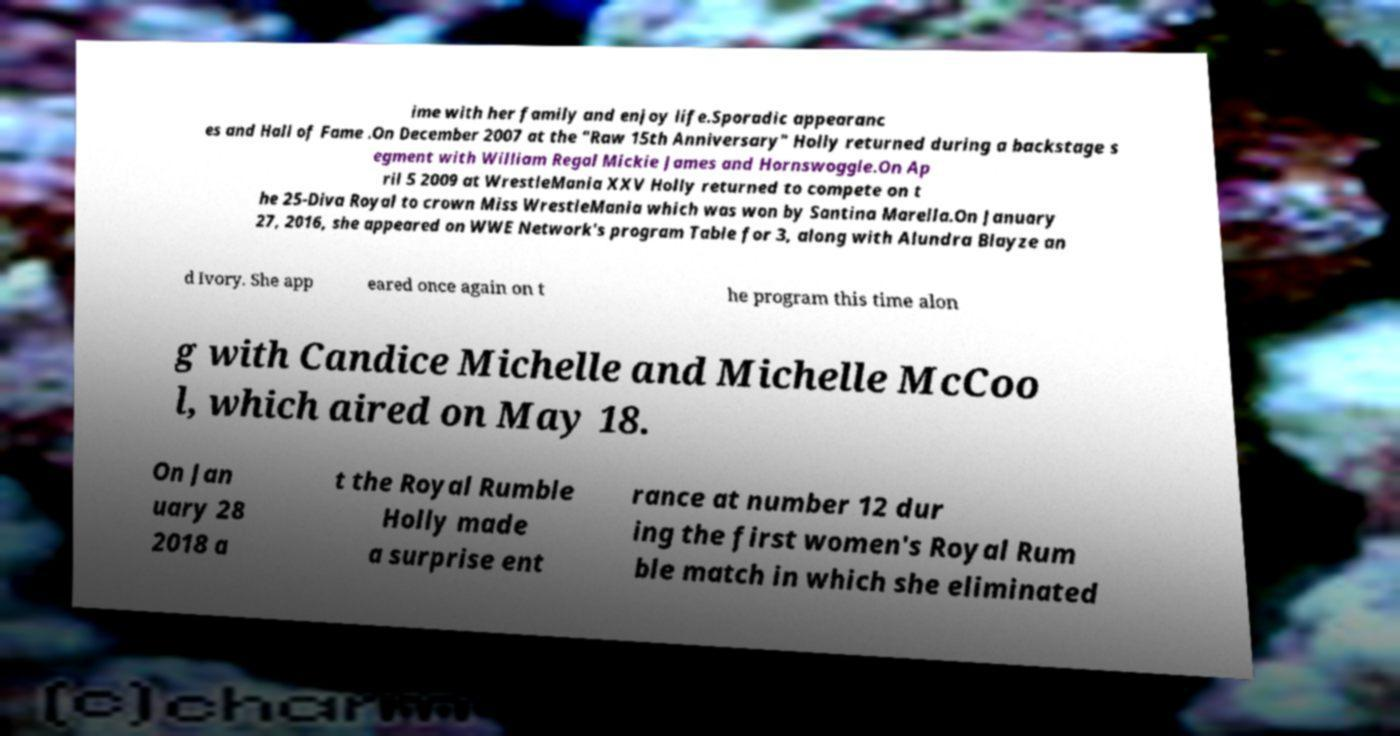Please identify and transcribe the text found in this image. ime with her family and enjoy life.Sporadic appearanc es and Hall of Fame .On December 2007 at the "Raw 15th Anniversary" Holly returned during a backstage s egment with William Regal Mickie James and Hornswoggle.On Ap ril 5 2009 at WrestleMania XXV Holly returned to compete on t he 25-Diva Royal to crown Miss WrestleMania which was won by Santina Marella.On January 27, 2016, she appeared on WWE Network's program Table for 3, along with Alundra Blayze an d Ivory. She app eared once again on t he program this time alon g with Candice Michelle and Michelle McCoo l, which aired on May 18. On Jan uary 28 2018 a t the Royal Rumble Holly made a surprise ent rance at number 12 dur ing the first women's Royal Rum ble match in which she eliminated 